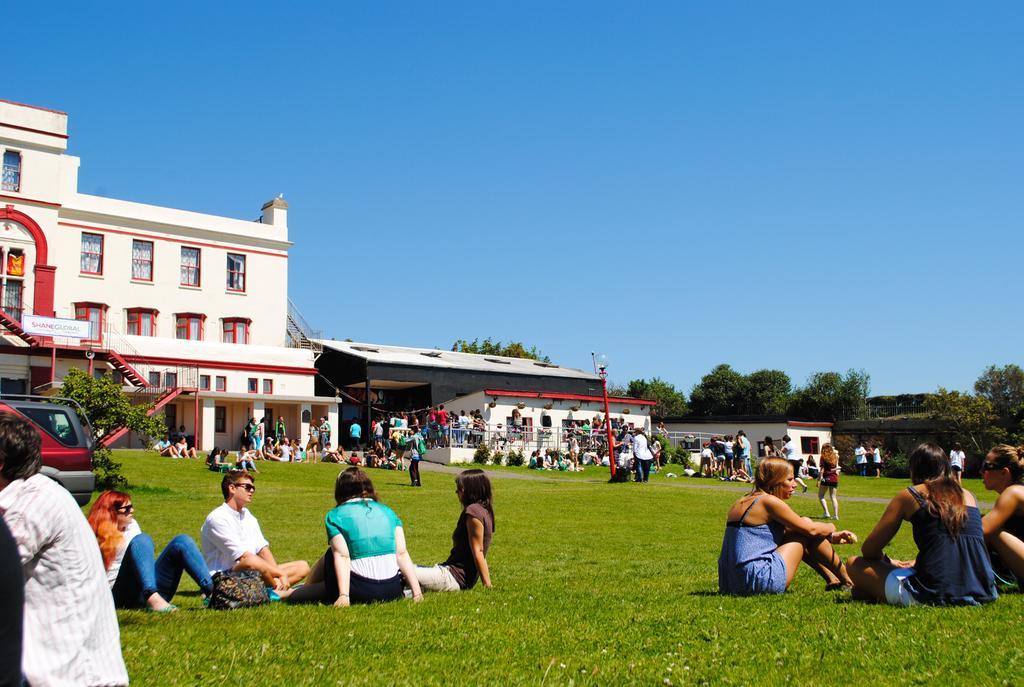Describe this image in one or two sentences. In this image I can see the ground, some grass on the ground, few trees, few persons standing, few persons sitting, few stairs, few buildings which are red , black and white in color, a red colored pole and a vehicle which is red and black in color. In the background I can see the sky. 